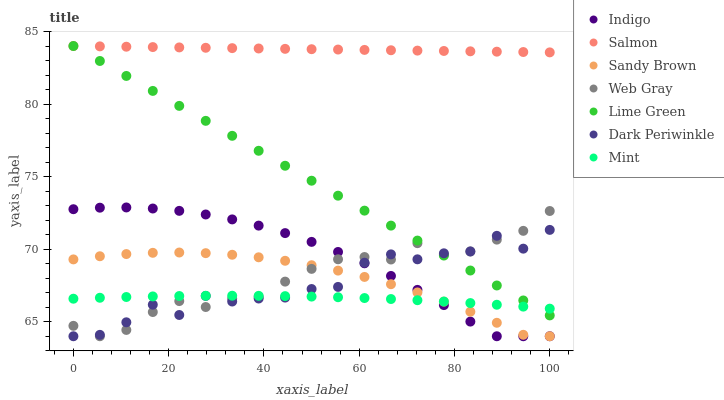Does Mint have the minimum area under the curve?
Answer yes or no. Yes. Does Salmon have the maximum area under the curve?
Answer yes or no. Yes. Does Indigo have the minimum area under the curve?
Answer yes or no. No. Does Indigo have the maximum area under the curve?
Answer yes or no. No. Is Salmon the smoothest?
Answer yes or no. Yes. Is Dark Periwinkle the roughest?
Answer yes or no. Yes. Is Indigo the smoothest?
Answer yes or no. No. Is Indigo the roughest?
Answer yes or no. No. Does Web Gray have the lowest value?
Answer yes or no. Yes. Does Salmon have the lowest value?
Answer yes or no. No. Does Lime Green have the highest value?
Answer yes or no. Yes. Does Indigo have the highest value?
Answer yes or no. No. Is Sandy Brown less than Salmon?
Answer yes or no. Yes. Is Lime Green greater than Sandy Brown?
Answer yes or no. Yes. Does Dark Periwinkle intersect Lime Green?
Answer yes or no. Yes. Is Dark Periwinkle less than Lime Green?
Answer yes or no. No. Is Dark Periwinkle greater than Lime Green?
Answer yes or no. No. Does Sandy Brown intersect Salmon?
Answer yes or no. No. 